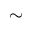Convert formula to latex. <formula><loc_0><loc_0><loc_500><loc_500>\sim</formula> 